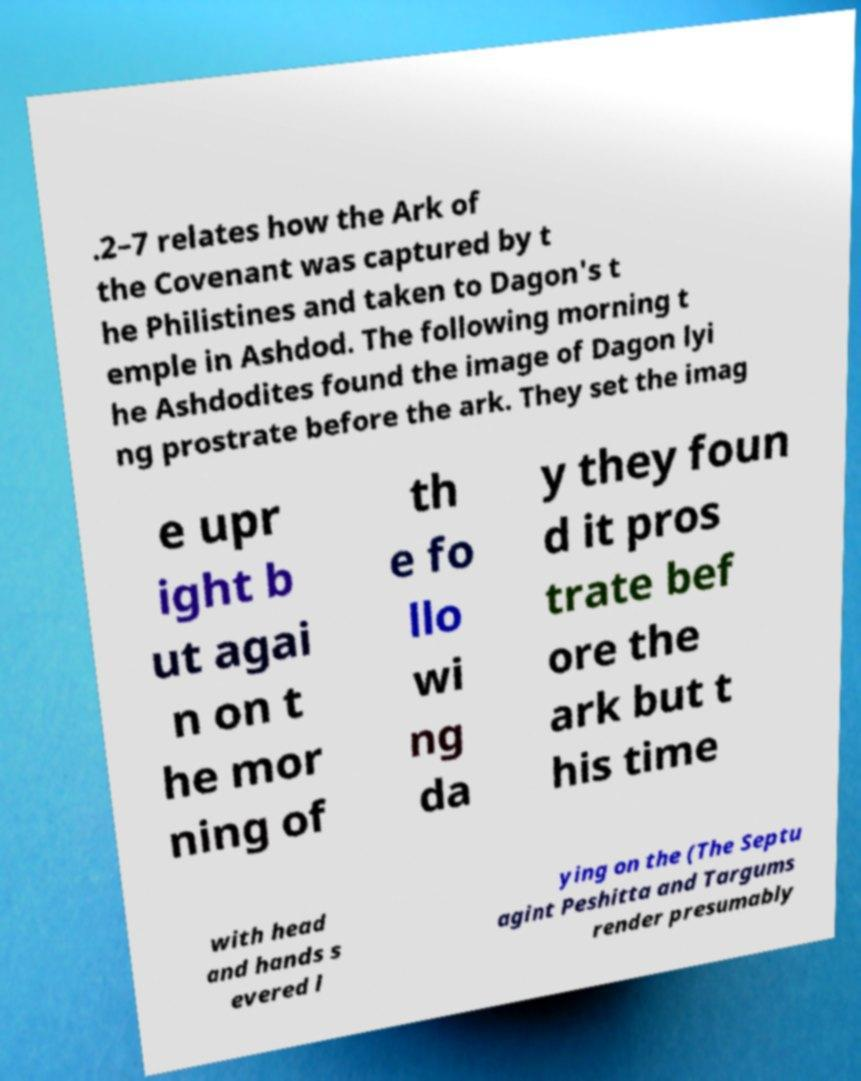Can you accurately transcribe the text from the provided image for me? .2–7 relates how the Ark of the Covenant was captured by t he Philistines and taken to Dagon's t emple in Ashdod. The following morning t he Ashdodites found the image of Dagon lyi ng prostrate before the ark. They set the imag e upr ight b ut agai n on t he mor ning of th e fo llo wi ng da y they foun d it pros trate bef ore the ark but t his time with head and hands s evered l ying on the (The Septu agint Peshitta and Targums render presumably 